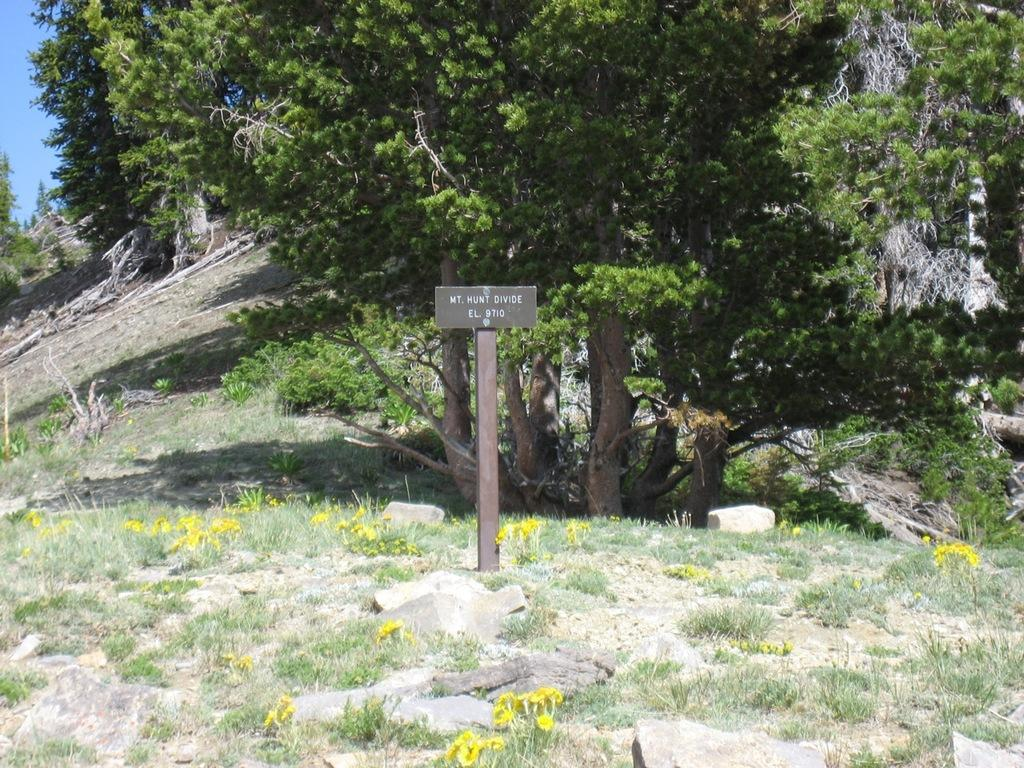What type of surface is visible in the image? There is a ground in the image. What covers the ground in the image? There is grass on the ground. Are there any other plants visible on the ground? Yes, there are flowers on the ground. What else can be seen in the image besides the ground and plants? There is a board with text in the image and trees. What is visible in the background of the image? The sky is visible in the image. How does the map adjust its position in the image? There is no map present in the image. Can you tell me how many breaths the flowers take in the image? Flowers do not breathe, and there is no indication of breathing in the image. 